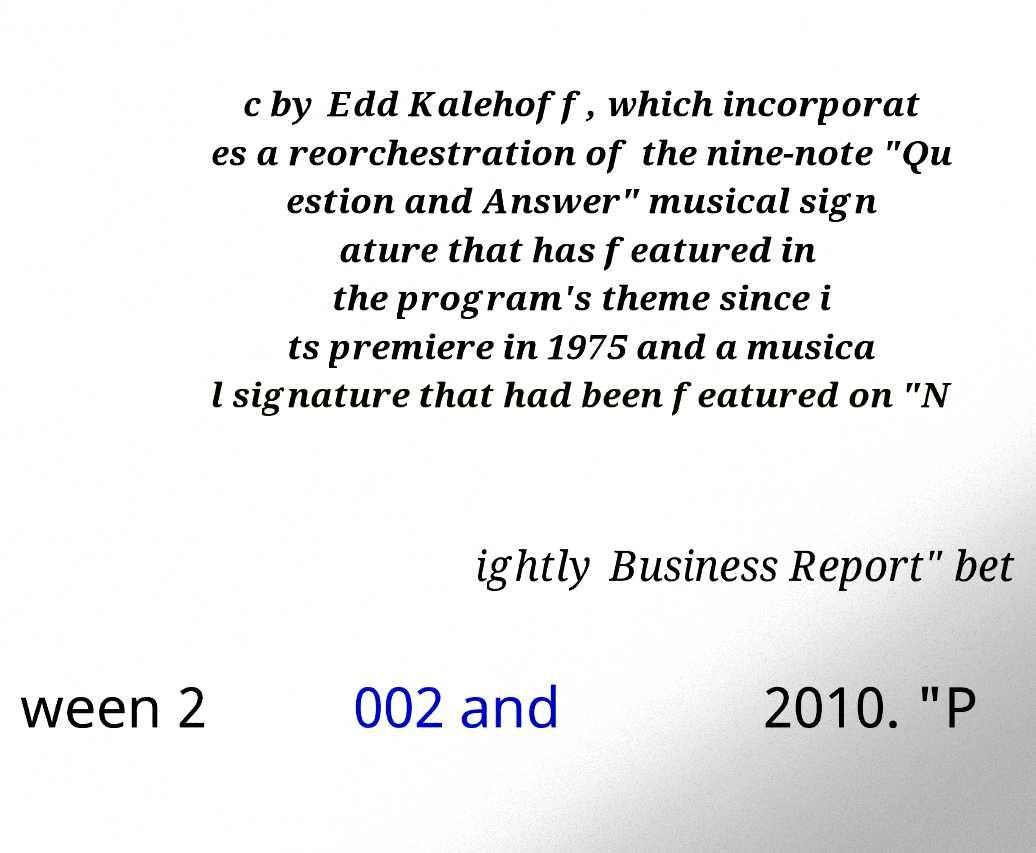Could you extract and type out the text from this image? c by Edd Kalehoff, which incorporat es a reorchestration of the nine-note "Qu estion and Answer" musical sign ature that has featured in the program's theme since i ts premiere in 1975 and a musica l signature that had been featured on "N ightly Business Report" bet ween 2 002 and 2010. "P 